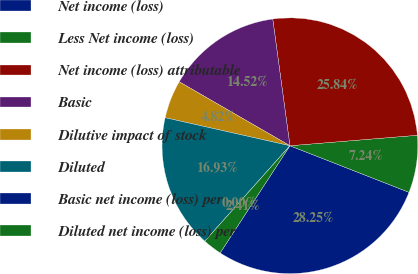Convert chart to OTSL. <chart><loc_0><loc_0><loc_500><loc_500><pie_chart><fcel>Net income (loss)<fcel>Less Net income (loss)<fcel>Net income (loss) attributable<fcel>Basic<fcel>Dilutive impact of stock<fcel>Diluted<fcel>Basic net income (loss) per<fcel>Diluted net income (loss) per<nl><fcel>28.25%<fcel>7.24%<fcel>25.84%<fcel>14.52%<fcel>4.82%<fcel>16.93%<fcel>0.0%<fcel>2.41%<nl></chart> 